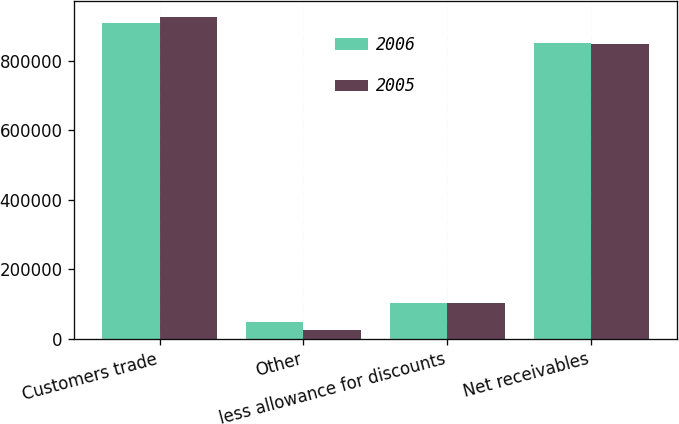Convert chart. <chart><loc_0><loc_0><loc_500><loc_500><stacked_bar_chart><ecel><fcel>Customers trade<fcel>Other<fcel>less allowance for discounts<fcel>Net receivables<nl><fcel>2006<fcel>907244<fcel>47798<fcel>103614<fcel>851428<nl><fcel>2005<fcel>925714<fcel>25662<fcel>102710<fcel>848666<nl></chart> 